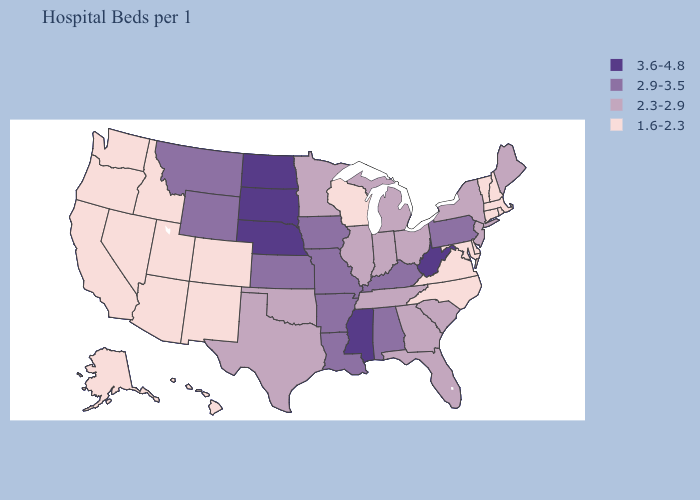Which states have the highest value in the USA?
Quick response, please. Mississippi, Nebraska, North Dakota, South Dakota, West Virginia. Does Tennessee have the same value as Connecticut?
Write a very short answer. No. What is the lowest value in states that border Delaware?
Short answer required. 1.6-2.3. Which states hav the highest value in the MidWest?
Short answer required. Nebraska, North Dakota, South Dakota. What is the highest value in the USA?
Answer briefly. 3.6-4.8. Name the states that have a value in the range 3.6-4.8?
Be succinct. Mississippi, Nebraska, North Dakota, South Dakota, West Virginia. Among the states that border Colorado , does Nebraska have the highest value?
Keep it brief. Yes. Does Nebraska have the highest value in the USA?
Answer briefly. Yes. Does the first symbol in the legend represent the smallest category?
Keep it brief. No. Which states have the lowest value in the USA?
Be succinct. Alaska, Arizona, California, Colorado, Connecticut, Delaware, Hawaii, Idaho, Maryland, Massachusetts, Nevada, New Hampshire, New Mexico, North Carolina, Oregon, Rhode Island, Utah, Vermont, Virginia, Washington, Wisconsin. What is the lowest value in states that border Texas?
Quick response, please. 1.6-2.3. What is the value of Iowa?
Write a very short answer. 2.9-3.5. Does the map have missing data?
Be succinct. No. Among the states that border Vermont , does New Hampshire have the lowest value?
Quick response, please. Yes. Does Massachusetts have the lowest value in the USA?
Answer briefly. Yes. 